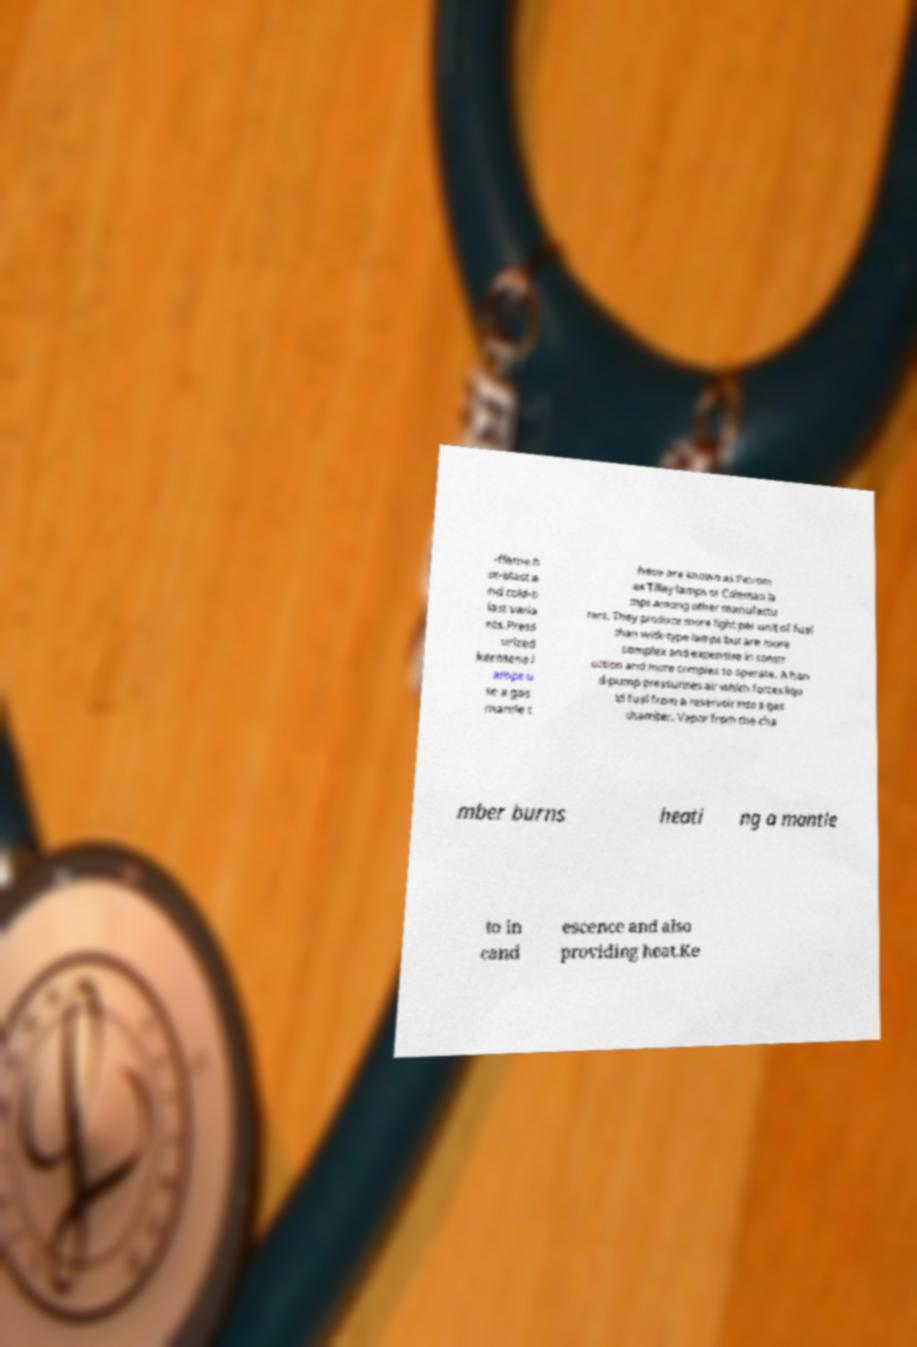I need the written content from this picture converted into text. Can you do that? -flame h ot-blast a nd cold-b last varia nts.Press urized kerosene l amps u se a gas mantle t hese are known as Petrom ax Tilley lamps or Coleman la mps among other manufactu rers. They produce more light per unit of fuel than wick-type lamps but are more complex and expensive in constr uction and more complex to operate. A han d-pump pressurizes air which forces liqu id fuel from a reservoir into a gas chamber. Vapor from the cha mber burns heati ng a mantle to in cand escence and also providing heat.Ke 